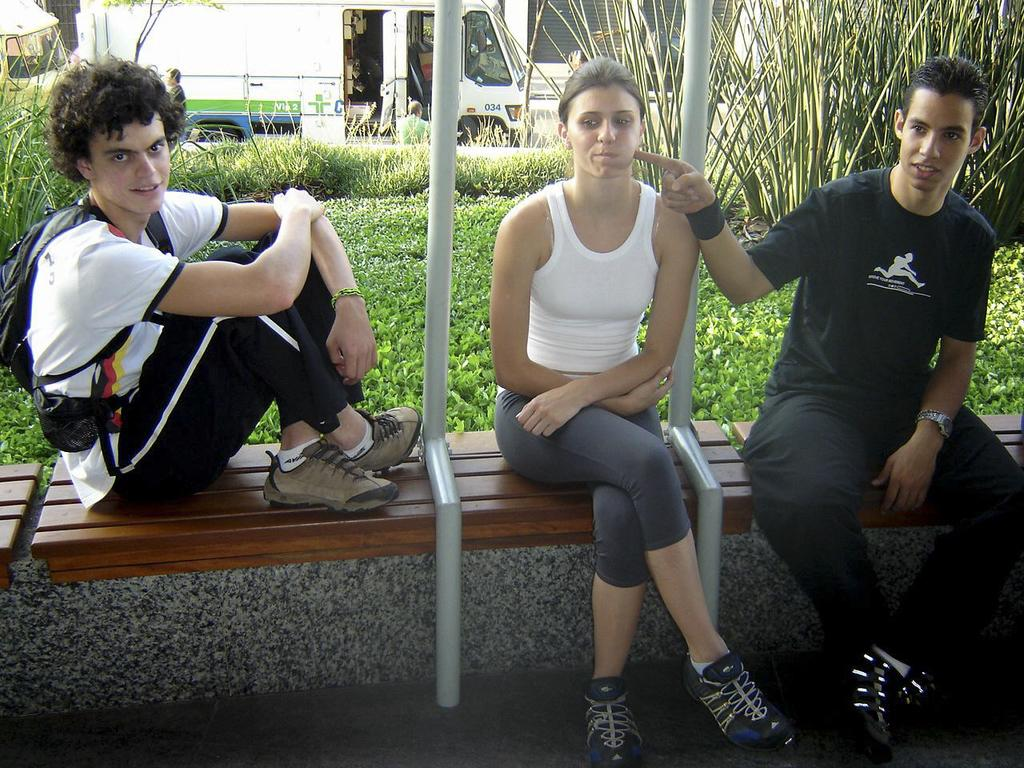What are the people in the image doing? The people in the image are sitting on a bench. What can be seen in the background of the image? There is grass and plants in the background of the image. Can you describe any objects or structures in the background? There is a vehicle visible in the background of the image. What type of button can be seen on the table in the image? There is no table or button present in the image. What color is the nose of the person sitting on the bench in the image? There is no nose visible in the image, as it is a photograph of people sitting on a bench and does not show their faces. 